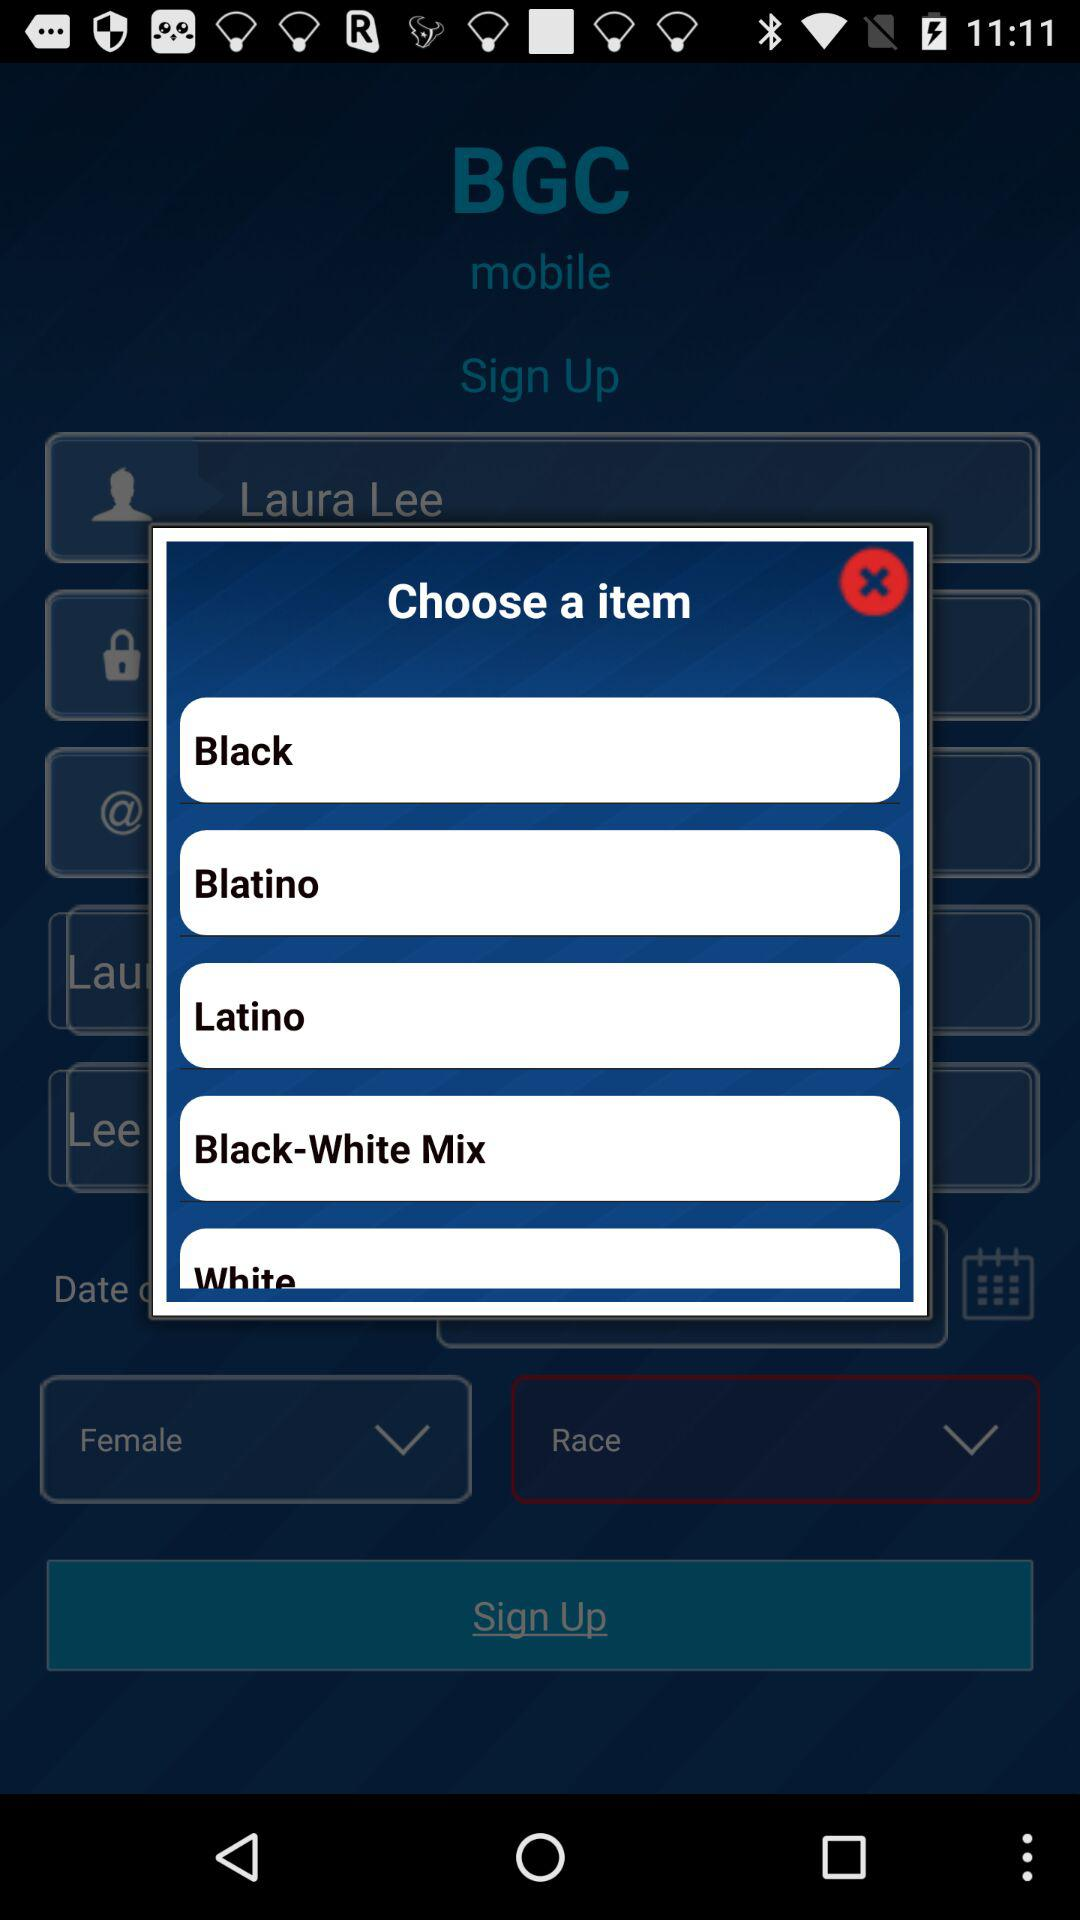What is the gender of the user? The gender of the user is female. 